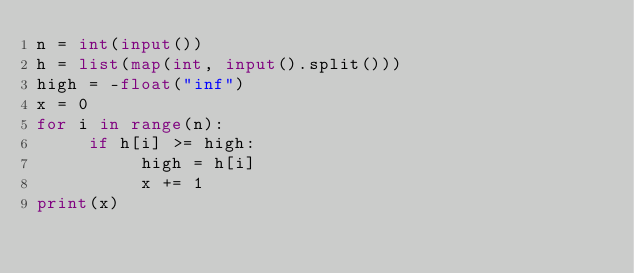Convert code to text. <code><loc_0><loc_0><loc_500><loc_500><_Python_>n = int(input())
h = list(map(int, input().split()))
high = -float("inf")
x = 0
for i in range(n):
     if h[i] >= high:
          high = h[i]
          x += 1
print(x)</code> 